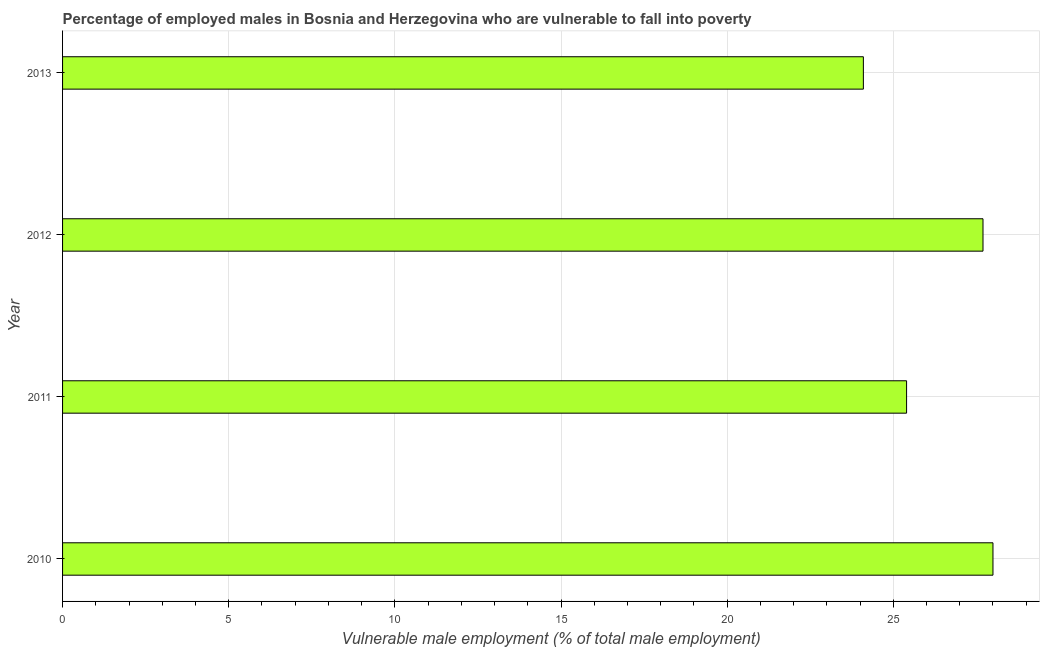What is the title of the graph?
Give a very brief answer. Percentage of employed males in Bosnia and Herzegovina who are vulnerable to fall into poverty. What is the label or title of the X-axis?
Make the answer very short. Vulnerable male employment (% of total male employment). What is the label or title of the Y-axis?
Ensure brevity in your answer.  Year. What is the percentage of employed males who are vulnerable to fall into poverty in 2011?
Your answer should be very brief. 25.4. Across all years, what is the maximum percentage of employed males who are vulnerable to fall into poverty?
Provide a short and direct response. 28. Across all years, what is the minimum percentage of employed males who are vulnerable to fall into poverty?
Provide a succinct answer. 24.1. What is the sum of the percentage of employed males who are vulnerable to fall into poverty?
Keep it short and to the point. 105.2. What is the average percentage of employed males who are vulnerable to fall into poverty per year?
Your answer should be compact. 26.3. What is the median percentage of employed males who are vulnerable to fall into poverty?
Offer a very short reply. 26.55. In how many years, is the percentage of employed males who are vulnerable to fall into poverty greater than 9 %?
Provide a succinct answer. 4. Do a majority of the years between 2010 and 2013 (inclusive) have percentage of employed males who are vulnerable to fall into poverty greater than 10 %?
Keep it short and to the point. Yes. What is the ratio of the percentage of employed males who are vulnerable to fall into poverty in 2011 to that in 2013?
Provide a succinct answer. 1.05. Is the difference between the percentage of employed males who are vulnerable to fall into poverty in 2010 and 2011 greater than the difference between any two years?
Ensure brevity in your answer.  No. How many years are there in the graph?
Provide a succinct answer. 4. What is the Vulnerable male employment (% of total male employment) in 2010?
Provide a succinct answer. 28. What is the Vulnerable male employment (% of total male employment) of 2011?
Offer a terse response. 25.4. What is the Vulnerable male employment (% of total male employment) of 2012?
Give a very brief answer. 27.7. What is the Vulnerable male employment (% of total male employment) in 2013?
Your response must be concise. 24.1. What is the difference between the Vulnerable male employment (% of total male employment) in 2010 and 2012?
Offer a terse response. 0.3. What is the difference between the Vulnerable male employment (% of total male employment) in 2010 and 2013?
Keep it short and to the point. 3.9. What is the difference between the Vulnerable male employment (% of total male employment) in 2011 and 2012?
Give a very brief answer. -2.3. What is the difference between the Vulnerable male employment (% of total male employment) in 2012 and 2013?
Your response must be concise. 3.6. What is the ratio of the Vulnerable male employment (% of total male employment) in 2010 to that in 2011?
Offer a very short reply. 1.1. What is the ratio of the Vulnerable male employment (% of total male employment) in 2010 to that in 2012?
Offer a terse response. 1.01. What is the ratio of the Vulnerable male employment (% of total male employment) in 2010 to that in 2013?
Offer a very short reply. 1.16. What is the ratio of the Vulnerable male employment (% of total male employment) in 2011 to that in 2012?
Your response must be concise. 0.92. What is the ratio of the Vulnerable male employment (% of total male employment) in 2011 to that in 2013?
Provide a succinct answer. 1.05. What is the ratio of the Vulnerable male employment (% of total male employment) in 2012 to that in 2013?
Keep it short and to the point. 1.15. 